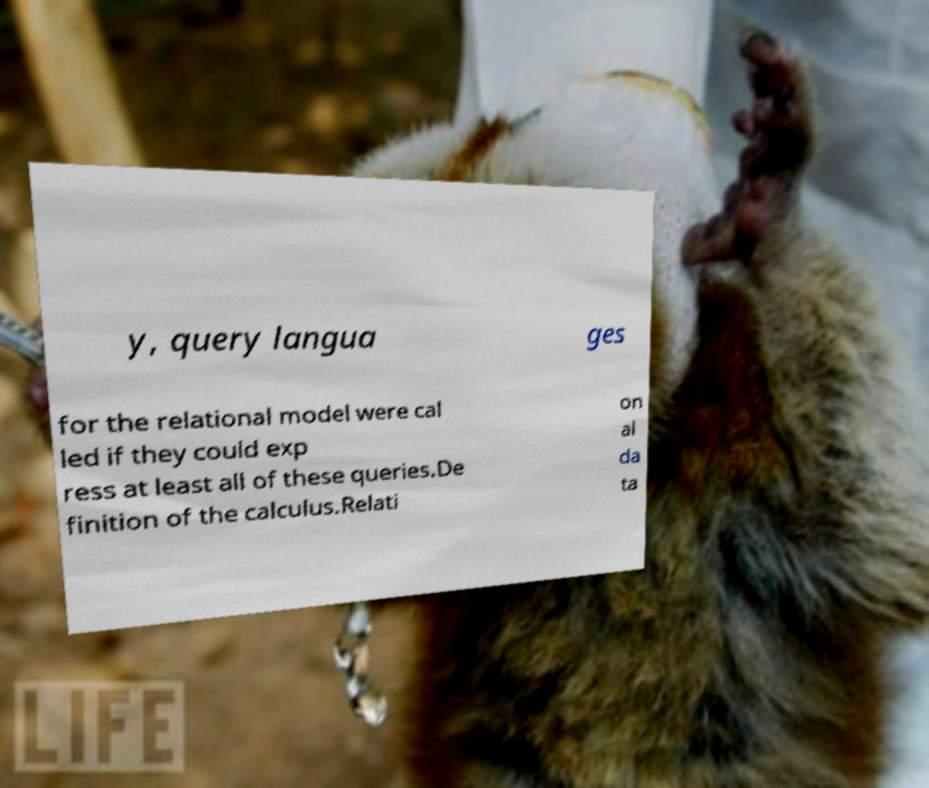Can you accurately transcribe the text from the provided image for me? y, query langua ges for the relational model were cal led if they could exp ress at least all of these queries.De finition of the calculus.Relati on al da ta 